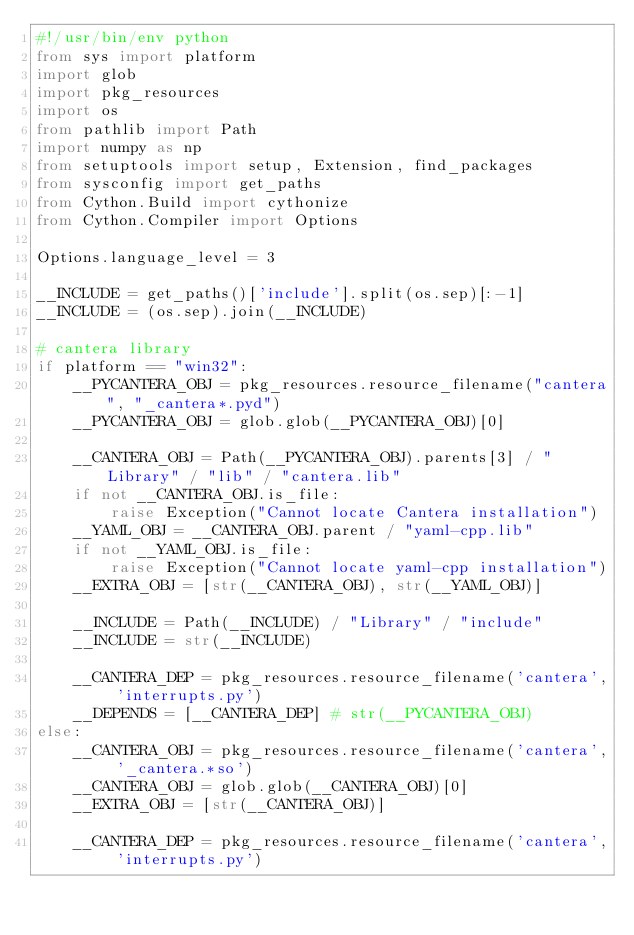Convert code to text. <code><loc_0><loc_0><loc_500><loc_500><_Python_>#!/usr/bin/env python
from sys import platform
import glob
import pkg_resources
import os
from pathlib import Path
import numpy as np
from setuptools import setup, Extension, find_packages
from sysconfig import get_paths
from Cython.Build import cythonize
from Cython.Compiler import Options

Options.language_level = 3

__INCLUDE = get_paths()['include'].split(os.sep)[:-1]
__INCLUDE = (os.sep).join(__INCLUDE)

# cantera library
if platform == "win32":
    __PYCANTERA_OBJ = pkg_resources.resource_filename("cantera", "_cantera*.pyd")
    __PYCANTERA_OBJ = glob.glob(__PYCANTERA_OBJ)[0]

    __CANTERA_OBJ = Path(__PYCANTERA_OBJ).parents[3] / "Library" / "lib" / "cantera.lib"
    if not __CANTERA_OBJ.is_file:
        raise Exception("Cannot locate Cantera installation")
    __YAML_OBJ = __CANTERA_OBJ.parent / "yaml-cpp.lib"
    if not __YAML_OBJ.is_file:
        raise Exception("Cannot locate yaml-cpp installation")
    __EXTRA_OBJ = [str(__CANTERA_OBJ), str(__YAML_OBJ)]

    __INCLUDE = Path(__INCLUDE) / "Library" / "include"
    __INCLUDE = str(__INCLUDE)

    __CANTERA_DEP = pkg_resources.resource_filename('cantera', 'interrupts.py')
    __DEPENDS = [__CANTERA_DEP] # str(__PYCANTERA_OBJ)
else:
    __CANTERA_OBJ = pkg_resources.resource_filename('cantera', '_cantera.*so')
    __CANTERA_OBJ = glob.glob(__CANTERA_OBJ)[0]
    __EXTRA_OBJ = [str(__CANTERA_OBJ)]

    __CANTERA_DEP = pkg_resources.resource_filename('cantera', 'interrupts.py')</code> 